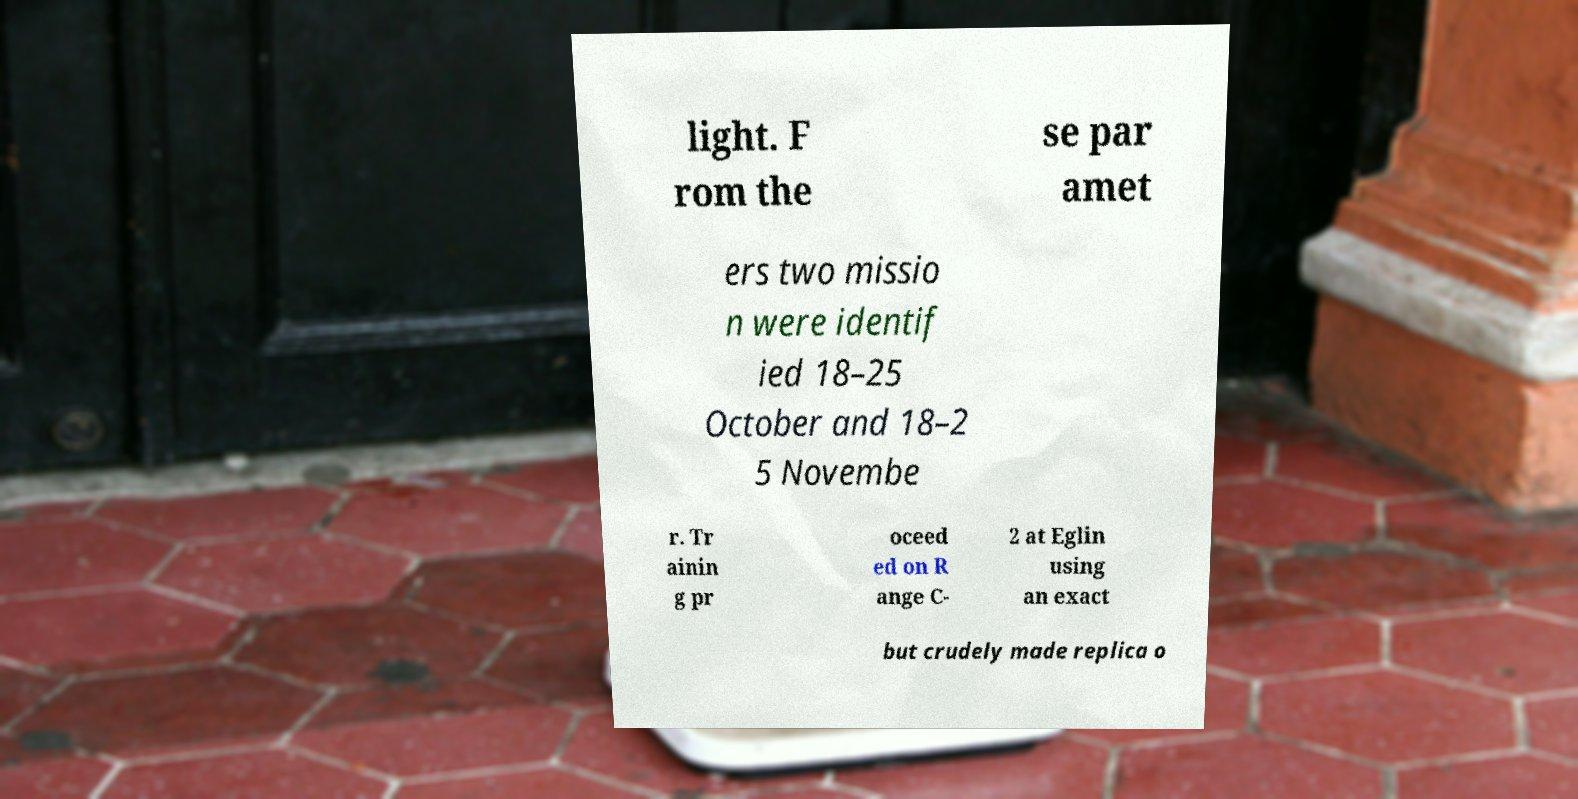Please read and relay the text visible in this image. What does it say? light. F rom the se par amet ers two missio n were identif ied 18–25 October and 18–2 5 Novembe r. Tr ainin g pr oceed ed on R ange C- 2 at Eglin using an exact but crudely made replica o 